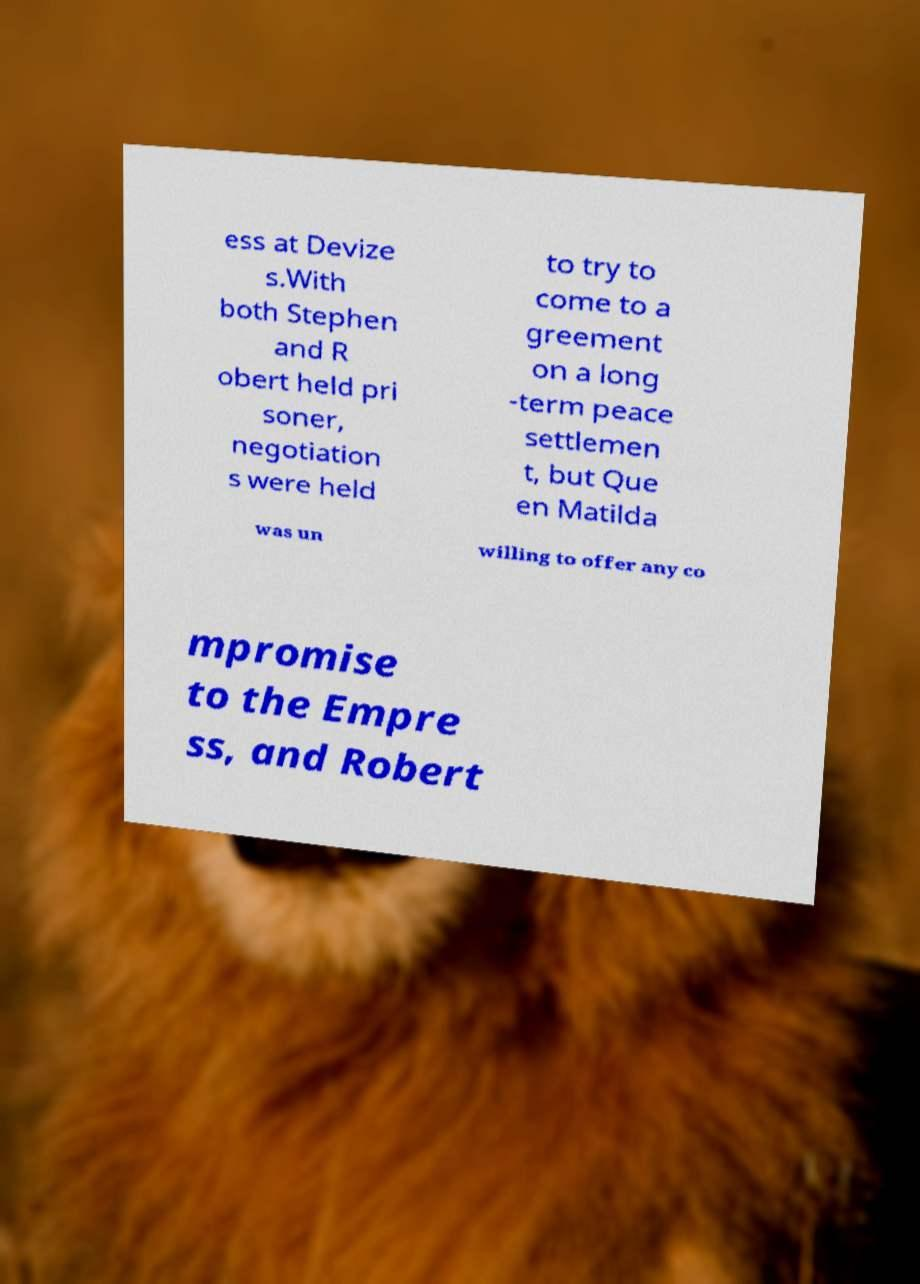I need the written content from this picture converted into text. Can you do that? ess at Devize s.With both Stephen and R obert held pri soner, negotiation s were held to try to come to a greement on a long -term peace settlemen t, but Que en Matilda was un willing to offer any co mpromise to the Empre ss, and Robert 